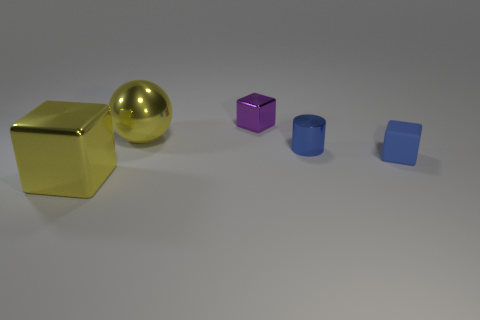Add 1 blue metallic blocks. How many objects exist? 6 Subtract all cylinders. How many objects are left? 4 Subtract all metallic cylinders. Subtract all tiny blue cylinders. How many objects are left? 3 Add 2 small metal cylinders. How many small metal cylinders are left? 3 Add 2 small purple cubes. How many small purple cubes exist? 3 Subtract 0 red cylinders. How many objects are left? 5 